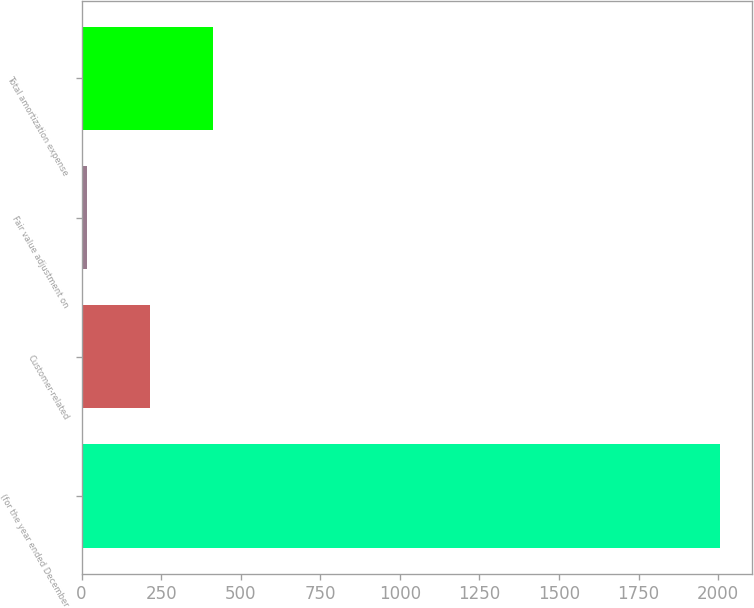<chart> <loc_0><loc_0><loc_500><loc_500><bar_chart><fcel>(for the year ended December<fcel>Customer-related<fcel>Fair value adjustment on<fcel>Total amortization expense<nl><fcel>2006<fcel>215<fcel>16<fcel>414<nl></chart> 